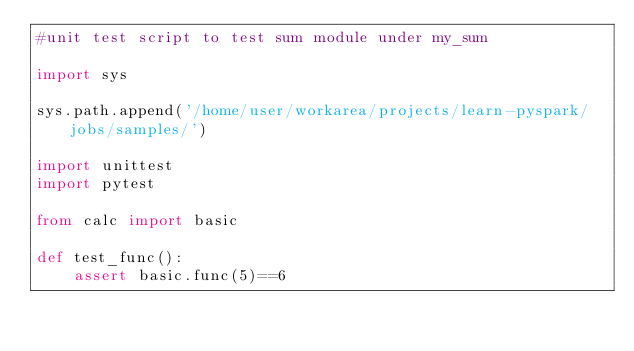Convert code to text. <code><loc_0><loc_0><loc_500><loc_500><_Python_>#unit test script to test sum module under my_sum

import sys

sys.path.append('/home/user/workarea/projects/learn-pyspark/jobs/samples/')

import unittest
import pytest

from calc import basic

def test_func():
    assert basic.func(5)==6
</code> 